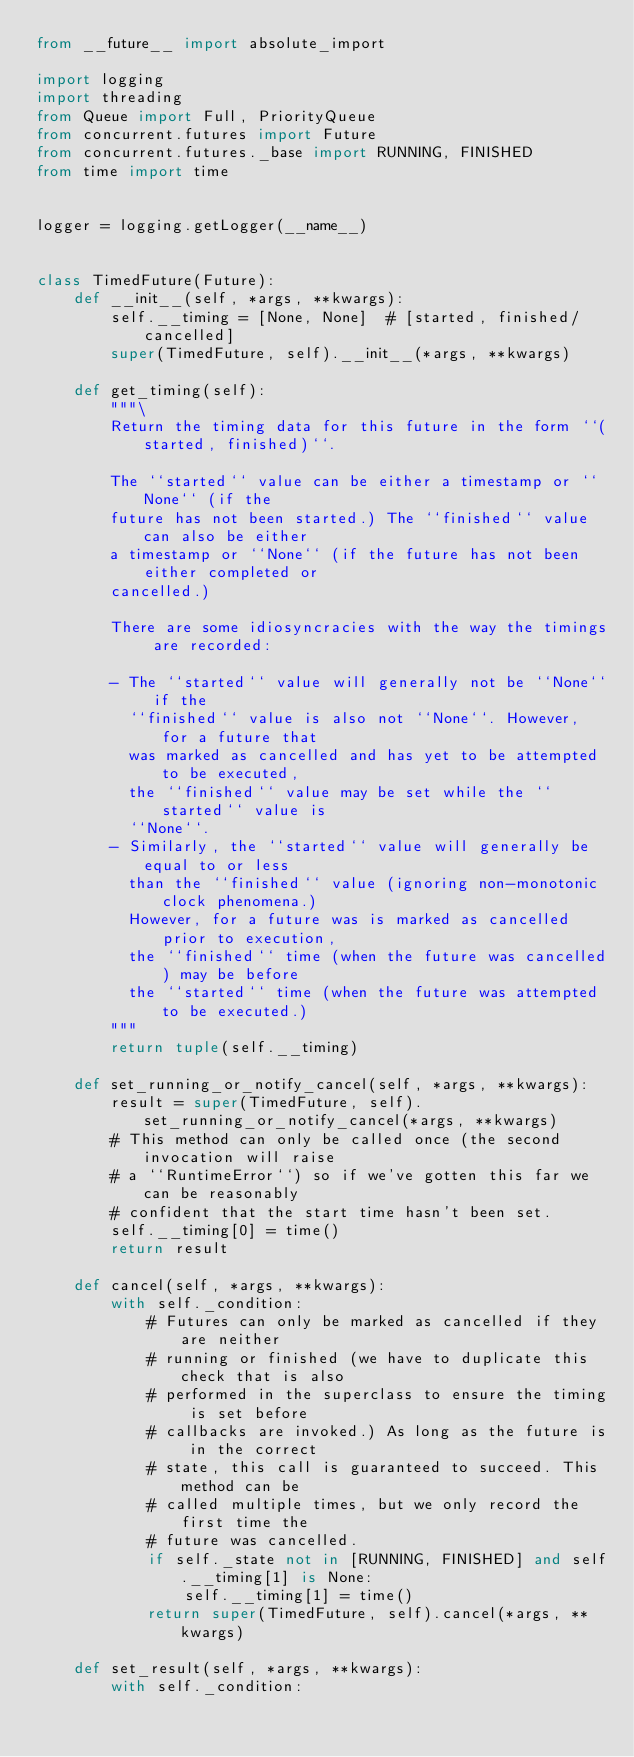Convert code to text. <code><loc_0><loc_0><loc_500><loc_500><_Python_>from __future__ import absolute_import

import logging
import threading
from Queue import Full, PriorityQueue
from concurrent.futures import Future
from concurrent.futures._base import RUNNING, FINISHED
from time import time


logger = logging.getLogger(__name__)


class TimedFuture(Future):
    def __init__(self, *args, **kwargs):
        self.__timing = [None, None]  # [started, finished/cancelled]
        super(TimedFuture, self).__init__(*args, **kwargs)

    def get_timing(self):
        """\
        Return the timing data for this future in the form ``(started, finished)``.

        The ``started`` value can be either a timestamp or ``None`` (if the
        future has not been started.) The ``finished`` value can also be either
        a timestamp or ``None`` (if the future has not been either completed or
        cancelled.)

        There are some idiosyncracies with the way the timings are recorded:

        - The ``started`` value will generally not be ``None`` if the
          ``finished`` value is also not ``None``. However, for a future that
          was marked as cancelled and has yet to be attempted to be executed,
          the ``finished`` value may be set while the ``started`` value is
          ``None``.
        - Similarly, the ``started`` value will generally be equal to or less
          than the ``finished`` value (ignoring non-monotonic clock phenomena.)
          However, for a future was is marked as cancelled prior to execution,
          the ``finished`` time (when the future was cancelled) may be before
          the ``started`` time (when the future was attempted to be executed.)
        """
        return tuple(self.__timing)

    def set_running_or_notify_cancel(self, *args, **kwargs):
        result = super(TimedFuture, self).set_running_or_notify_cancel(*args, **kwargs)
        # This method can only be called once (the second invocation will raise
        # a ``RuntimeError``) so if we've gotten this far we can be reasonably
        # confident that the start time hasn't been set.
        self.__timing[0] = time()
        return result

    def cancel(self, *args, **kwargs):
        with self._condition:
            # Futures can only be marked as cancelled if they are neither
            # running or finished (we have to duplicate this check that is also
            # performed in the superclass to ensure the timing is set before
            # callbacks are invoked.) As long as the future is in the correct
            # state, this call is guaranteed to succeed. This method can be
            # called multiple times, but we only record the first time the
            # future was cancelled.
            if self._state not in [RUNNING, FINISHED] and self.__timing[1] is None:
                self.__timing[1] = time()
            return super(TimedFuture, self).cancel(*args, **kwargs)

    def set_result(self, *args, **kwargs):
        with self._condition:</code> 